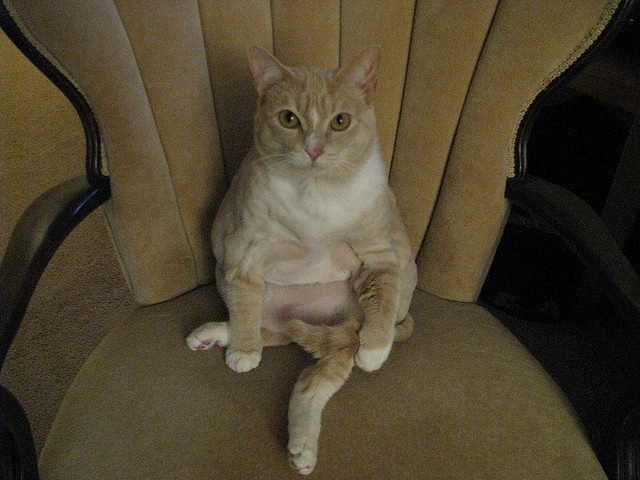Describe the objects in this image and their specific colors. I can see chair in olive, black, and gray tones and cat in black and gray tones in this image. 